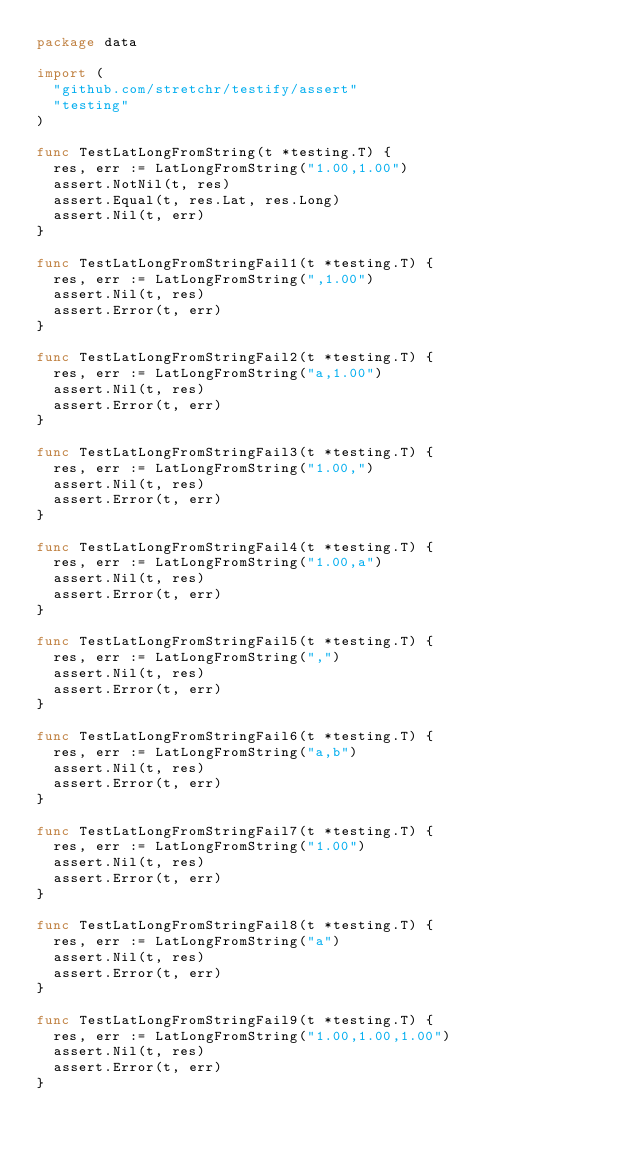Convert code to text. <code><loc_0><loc_0><loc_500><loc_500><_Go_>package data

import (
	"github.com/stretchr/testify/assert"
	"testing"
)

func TestLatLongFromString(t *testing.T) {
	res, err := LatLongFromString("1.00,1.00")
	assert.NotNil(t, res)
	assert.Equal(t, res.Lat, res.Long)
	assert.Nil(t, err)
}

func TestLatLongFromStringFail1(t *testing.T) {
	res, err := LatLongFromString(",1.00")
	assert.Nil(t, res)
	assert.Error(t, err)
}

func TestLatLongFromStringFail2(t *testing.T) {
	res, err := LatLongFromString("a,1.00")
	assert.Nil(t, res)
	assert.Error(t, err)
}

func TestLatLongFromStringFail3(t *testing.T) {
	res, err := LatLongFromString("1.00,")
	assert.Nil(t, res)
	assert.Error(t, err)
}

func TestLatLongFromStringFail4(t *testing.T) {
	res, err := LatLongFromString("1.00,a")
	assert.Nil(t, res)
	assert.Error(t, err)
}

func TestLatLongFromStringFail5(t *testing.T) {
	res, err := LatLongFromString(",")
	assert.Nil(t, res)
	assert.Error(t, err)
}

func TestLatLongFromStringFail6(t *testing.T) {
	res, err := LatLongFromString("a,b")
	assert.Nil(t, res)
	assert.Error(t, err)
}

func TestLatLongFromStringFail7(t *testing.T) {
	res, err := LatLongFromString("1.00")
	assert.Nil(t, res)
	assert.Error(t, err)
}

func TestLatLongFromStringFail8(t *testing.T) {
	res, err := LatLongFromString("a")
	assert.Nil(t, res)
	assert.Error(t, err)
}

func TestLatLongFromStringFail9(t *testing.T) {
	res, err := LatLongFromString("1.00,1.00,1.00")
	assert.Nil(t, res)
	assert.Error(t, err)
}
</code> 